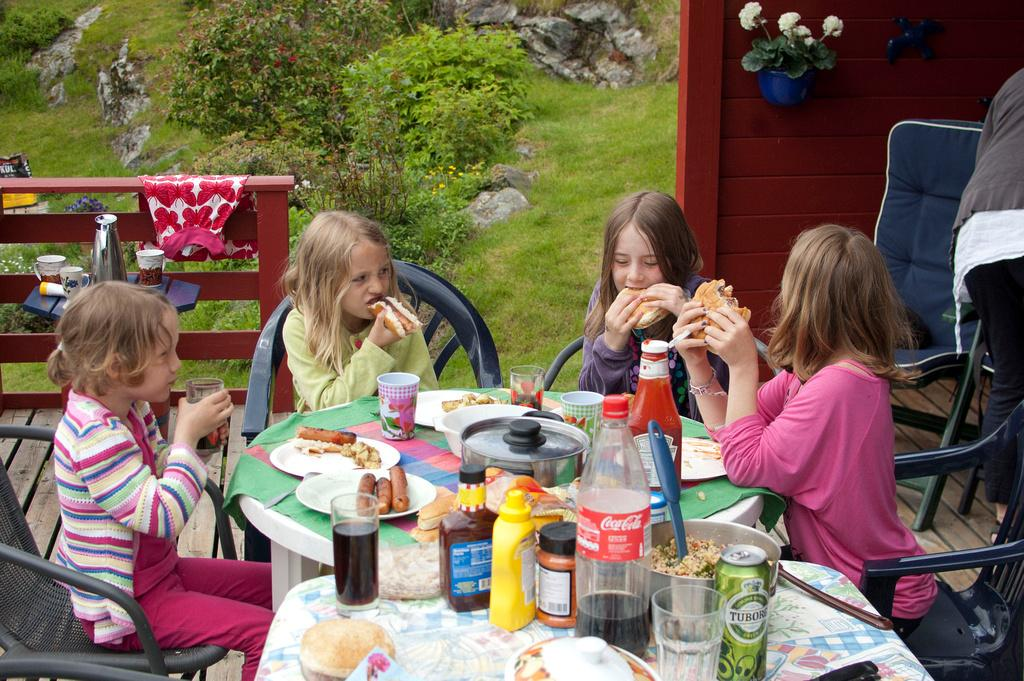How many people are sitting in the image? There are four persons sitting in the image. What are the persons sitting on? The persons are sitting in chairs. What are the persons doing while sitting? The persons are eating. What objects can be seen on the table? There are plates and bottles on the table. What can be seen in the background of the image? The background of the image includes grass and trees. What color are the grass and trees in the image? The grass and trees are green in color. What type of oatmeal is being served to the persons in the image? There is no oatmeal present in the image; the persons are eating, but the specific food is not mentioned. 